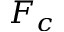Convert formula to latex. <formula><loc_0><loc_0><loc_500><loc_500>F _ { c }</formula> 